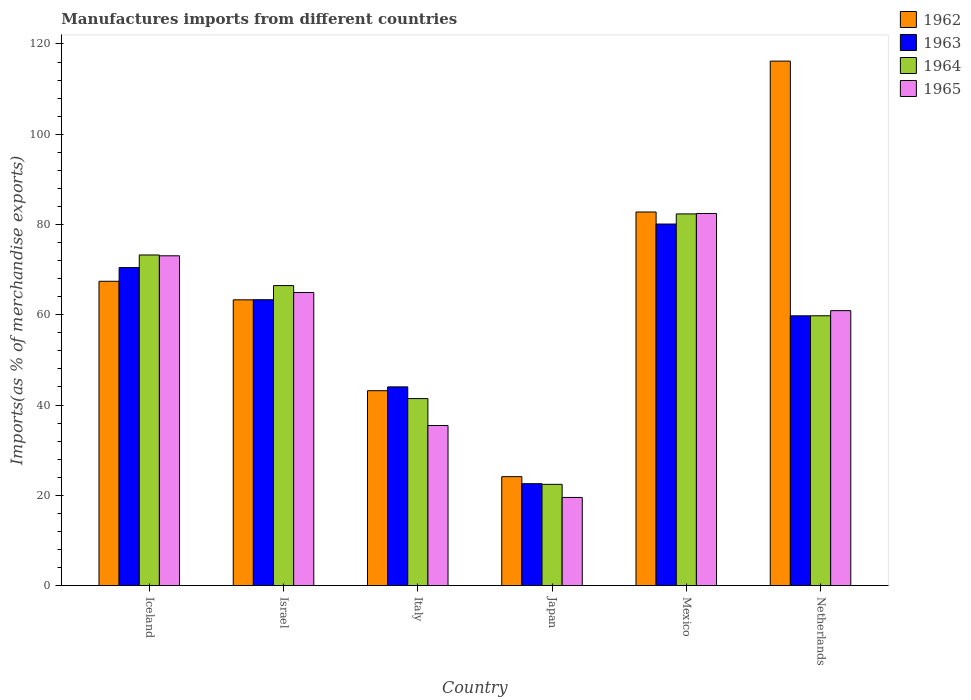How many different coloured bars are there?
Ensure brevity in your answer.  4. Are the number of bars per tick equal to the number of legend labels?
Provide a succinct answer. Yes. Are the number of bars on each tick of the X-axis equal?
Your answer should be compact. Yes. What is the label of the 3rd group of bars from the left?
Offer a terse response. Italy. In how many cases, is the number of bars for a given country not equal to the number of legend labels?
Make the answer very short. 0. What is the percentage of imports to different countries in 1964 in Iceland?
Your answer should be very brief. 73.25. Across all countries, what is the maximum percentage of imports to different countries in 1962?
Keep it short and to the point. 116.21. Across all countries, what is the minimum percentage of imports to different countries in 1965?
Provide a succinct answer. 19.52. In which country was the percentage of imports to different countries in 1962 maximum?
Provide a short and direct response. Netherlands. What is the total percentage of imports to different countries in 1963 in the graph?
Make the answer very short. 340.27. What is the difference between the percentage of imports to different countries in 1965 in Iceland and that in Japan?
Give a very brief answer. 53.54. What is the difference between the percentage of imports to different countries in 1962 in Netherlands and the percentage of imports to different countries in 1965 in Iceland?
Your response must be concise. 43.14. What is the average percentage of imports to different countries in 1964 per country?
Your response must be concise. 57.62. What is the difference between the percentage of imports to different countries of/in 1965 and percentage of imports to different countries of/in 1964 in Mexico?
Keep it short and to the point. 0.09. What is the ratio of the percentage of imports to different countries in 1965 in Israel to that in Netherlands?
Make the answer very short. 1.07. Is the percentage of imports to different countries in 1965 in Israel less than that in Italy?
Provide a short and direct response. No. What is the difference between the highest and the second highest percentage of imports to different countries in 1963?
Offer a very short reply. 9.65. What is the difference between the highest and the lowest percentage of imports to different countries in 1965?
Provide a succinct answer. 62.92. Is it the case that in every country, the sum of the percentage of imports to different countries in 1964 and percentage of imports to different countries in 1962 is greater than the sum of percentage of imports to different countries in 1963 and percentage of imports to different countries in 1965?
Ensure brevity in your answer.  No. What does the 4th bar from the left in Italy represents?
Keep it short and to the point. 1965. What does the 1st bar from the right in Israel represents?
Make the answer very short. 1965. Is it the case that in every country, the sum of the percentage of imports to different countries in 1964 and percentage of imports to different countries in 1963 is greater than the percentage of imports to different countries in 1962?
Offer a terse response. Yes. How many bars are there?
Give a very brief answer. 24. Are all the bars in the graph horizontal?
Offer a very short reply. No. How many countries are there in the graph?
Give a very brief answer. 6. Are the values on the major ticks of Y-axis written in scientific E-notation?
Offer a terse response. No. Does the graph contain any zero values?
Your answer should be very brief. No. Does the graph contain grids?
Give a very brief answer. No. Where does the legend appear in the graph?
Make the answer very short. Top right. How many legend labels are there?
Your answer should be compact. 4. How are the legend labels stacked?
Offer a terse response. Vertical. What is the title of the graph?
Your answer should be compact. Manufactures imports from different countries. What is the label or title of the X-axis?
Make the answer very short. Country. What is the label or title of the Y-axis?
Your answer should be very brief. Imports(as % of merchandise exports). What is the Imports(as % of merchandise exports) in 1962 in Iceland?
Your answer should be compact. 67.42. What is the Imports(as % of merchandise exports) of 1963 in Iceland?
Offer a terse response. 70.45. What is the Imports(as % of merchandise exports) of 1964 in Iceland?
Give a very brief answer. 73.25. What is the Imports(as % of merchandise exports) of 1965 in Iceland?
Ensure brevity in your answer.  73.07. What is the Imports(as % of merchandise exports) in 1962 in Israel?
Your answer should be compact. 63.32. What is the Imports(as % of merchandise exports) of 1963 in Israel?
Give a very brief answer. 63.34. What is the Imports(as % of merchandise exports) in 1964 in Israel?
Offer a very short reply. 66.47. What is the Imports(as % of merchandise exports) of 1965 in Israel?
Ensure brevity in your answer.  64.94. What is the Imports(as % of merchandise exports) in 1962 in Italy?
Give a very brief answer. 43.18. What is the Imports(as % of merchandise exports) of 1963 in Italy?
Ensure brevity in your answer.  44.02. What is the Imports(as % of merchandise exports) of 1964 in Italy?
Your response must be concise. 41.43. What is the Imports(as % of merchandise exports) of 1965 in Italy?
Offer a terse response. 35.47. What is the Imports(as % of merchandise exports) in 1962 in Japan?
Make the answer very short. 24.13. What is the Imports(as % of merchandise exports) in 1963 in Japan?
Give a very brief answer. 22.57. What is the Imports(as % of merchandise exports) of 1964 in Japan?
Offer a terse response. 22.43. What is the Imports(as % of merchandise exports) of 1965 in Japan?
Make the answer very short. 19.52. What is the Imports(as % of merchandise exports) of 1962 in Mexico?
Keep it short and to the point. 82.78. What is the Imports(as % of merchandise exports) in 1963 in Mexico?
Your response must be concise. 80.11. What is the Imports(as % of merchandise exports) of 1964 in Mexico?
Provide a short and direct response. 82.35. What is the Imports(as % of merchandise exports) of 1965 in Mexico?
Your answer should be very brief. 82.44. What is the Imports(as % of merchandise exports) in 1962 in Netherlands?
Keep it short and to the point. 116.21. What is the Imports(as % of merchandise exports) in 1963 in Netherlands?
Offer a very short reply. 59.77. What is the Imports(as % of merchandise exports) of 1964 in Netherlands?
Provide a succinct answer. 59.78. What is the Imports(as % of merchandise exports) of 1965 in Netherlands?
Your response must be concise. 60.91. Across all countries, what is the maximum Imports(as % of merchandise exports) of 1962?
Make the answer very short. 116.21. Across all countries, what is the maximum Imports(as % of merchandise exports) in 1963?
Your response must be concise. 80.11. Across all countries, what is the maximum Imports(as % of merchandise exports) in 1964?
Your response must be concise. 82.35. Across all countries, what is the maximum Imports(as % of merchandise exports) of 1965?
Give a very brief answer. 82.44. Across all countries, what is the minimum Imports(as % of merchandise exports) in 1962?
Offer a terse response. 24.13. Across all countries, what is the minimum Imports(as % of merchandise exports) of 1963?
Provide a succinct answer. 22.57. Across all countries, what is the minimum Imports(as % of merchandise exports) of 1964?
Make the answer very short. 22.43. Across all countries, what is the minimum Imports(as % of merchandise exports) in 1965?
Offer a terse response. 19.52. What is the total Imports(as % of merchandise exports) of 1962 in the graph?
Make the answer very short. 397.04. What is the total Imports(as % of merchandise exports) of 1963 in the graph?
Offer a very short reply. 340.27. What is the total Imports(as % of merchandise exports) in 1964 in the graph?
Provide a short and direct response. 345.71. What is the total Imports(as % of merchandise exports) of 1965 in the graph?
Give a very brief answer. 336.36. What is the difference between the Imports(as % of merchandise exports) of 1962 in Iceland and that in Israel?
Ensure brevity in your answer.  4.11. What is the difference between the Imports(as % of merchandise exports) in 1963 in Iceland and that in Israel?
Your answer should be compact. 7.11. What is the difference between the Imports(as % of merchandise exports) of 1964 in Iceland and that in Israel?
Provide a succinct answer. 6.78. What is the difference between the Imports(as % of merchandise exports) of 1965 in Iceland and that in Israel?
Provide a short and direct response. 8.12. What is the difference between the Imports(as % of merchandise exports) of 1962 in Iceland and that in Italy?
Offer a terse response. 24.24. What is the difference between the Imports(as % of merchandise exports) in 1963 in Iceland and that in Italy?
Make the answer very short. 26.43. What is the difference between the Imports(as % of merchandise exports) in 1964 in Iceland and that in Italy?
Make the answer very short. 31.82. What is the difference between the Imports(as % of merchandise exports) of 1965 in Iceland and that in Italy?
Provide a short and direct response. 37.6. What is the difference between the Imports(as % of merchandise exports) in 1962 in Iceland and that in Japan?
Provide a succinct answer. 43.29. What is the difference between the Imports(as % of merchandise exports) in 1963 in Iceland and that in Japan?
Offer a terse response. 47.88. What is the difference between the Imports(as % of merchandise exports) of 1964 in Iceland and that in Japan?
Keep it short and to the point. 50.82. What is the difference between the Imports(as % of merchandise exports) of 1965 in Iceland and that in Japan?
Make the answer very short. 53.54. What is the difference between the Imports(as % of merchandise exports) in 1962 in Iceland and that in Mexico?
Give a very brief answer. -15.35. What is the difference between the Imports(as % of merchandise exports) in 1963 in Iceland and that in Mexico?
Make the answer very short. -9.65. What is the difference between the Imports(as % of merchandise exports) of 1964 in Iceland and that in Mexico?
Keep it short and to the point. -9.1. What is the difference between the Imports(as % of merchandise exports) of 1965 in Iceland and that in Mexico?
Make the answer very short. -9.38. What is the difference between the Imports(as % of merchandise exports) in 1962 in Iceland and that in Netherlands?
Your answer should be very brief. -48.79. What is the difference between the Imports(as % of merchandise exports) in 1963 in Iceland and that in Netherlands?
Your answer should be compact. 10.68. What is the difference between the Imports(as % of merchandise exports) of 1964 in Iceland and that in Netherlands?
Your answer should be compact. 13.47. What is the difference between the Imports(as % of merchandise exports) of 1965 in Iceland and that in Netherlands?
Provide a short and direct response. 12.15. What is the difference between the Imports(as % of merchandise exports) of 1962 in Israel and that in Italy?
Give a very brief answer. 20.14. What is the difference between the Imports(as % of merchandise exports) of 1963 in Israel and that in Italy?
Provide a short and direct response. 19.32. What is the difference between the Imports(as % of merchandise exports) of 1964 in Israel and that in Italy?
Make the answer very short. 25.04. What is the difference between the Imports(as % of merchandise exports) of 1965 in Israel and that in Italy?
Give a very brief answer. 29.47. What is the difference between the Imports(as % of merchandise exports) in 1962 in Israel and that in Japan?
Keep it short and to the point. 39.19. What is the difference between the Imports(as % of merchandise exports) of 1963 in Israel and that in Japan?
Give a very brief answer. 40.77. What is the difference between the Imports(as % of merchandise exports) in 1964 in Israel and that in Japan?
Keep it short and to the point. 44.04. What is the difference between the Imports(as % of merchandise exports) in 1965 in Israel and that in Japan?
Keep it short and to the point. 45.42. What is the difference between the Imports(as % of merchandise exports) of 1962 in Israel and that in Mexico?
Offer a terse response. -19.46. What is the difference between the Imports(as % of merchandise exports) in 1963 in Israel and that in Mexico?
Provide a short and direct response. -16.77. What is the difference between the Imports(as % of merchandise exports) in 1964 in Israel and that in Mexico?
Make the answer very short. -15.88. What is the difference between the Imports(as % of merchandise exports) of 1965 in Israel and that in Mexico?
Give a very brief answer. -17.5. What is the difference between the Imports(as % of merchandise exports) in 1962 in Israel and that in Netherlands?
Your response must be concise. -52.9. What is the difference between the Imports(as % of merchandise exports) in 1963 in Israel and that in Netherlands?
Your response must be concise. 3.57. What is the difference between the Imports(as % of merchandise exports) in 1964 in Israel and that in Netherlands?
Provide a short and direct response. 6.69. What is the difference between the Imports(as % of merchandise exports) in 1965 in Israel and that in Netherlands?
Provide a succinct answer. 4.03. What is the difference between the Imports(as % of merchandise exports) in 1962 in Italy and that in Japan?
Give a very brief answer. 19.05. What is the difference between the Imports(as % of merchandise exports) in 1963 in Italy and that in Japan?
Offer a terse response. 21.45. What is the difference between the Imports(as % of merchandise exports) of 1964 in Italy and that in Japan?
Provide a short and direct response. 19. What is the difference between the Imports(as % of merchandise exports) in 1965 in Italy and that in Japan?
Provide a succinct answer. 15.94. What is the difference between the Imports(as % of merchandise exports) of 1962 in Italy and that in Mexico?
Your response must be concise. -39.6. What is the difference between the Imports(as % of merchandise exports) in 1963 in Italy and that in Mexico?
Your response must be concise. -36.08. What is the difference between the Imports(as % of merchandise exports) of 1964 in Italy and that in Mexico?
Ensure brevity in your answer.  -40.92. What is the difference between the Imports(as % of merchandise exports) in 1965 in Italy and that in Mexico?
Provide a succinct answer. -46.98. What is the difference between the Imports(as % of merchandise exports) in 1962 in Italy and that in Netherlands?
Your response must be concise. -73.03. What is the difference between the Imports(as % of merchandise exports) of 1963 in Italy and that in Netherlands?
Offer a terse response. -15.75. What is the difference between the Imports(as % of merchandise exports) of 1964 in Italy and that in Netherlands?
Keep it short and to the point. -18.35. What is the difference between the Imports(as % of merchandise exports) of 1965 in Italy and that in Netherlands?
Offer a very short reply. -25.45. What is the difference between the Imports(as % of merchandise exports) in 1962 in Japan and that in Mexico?
Your answer should be compact. -58.65. What is the difference between the Imports(as % of merchandise exports) in 1963 in Japan and that in Mexico?
Offer a terse response. -57.53. What is the difference between the Imports(as % of merchandise exports) of 1964 in Japan and that in Mexico?
Your answer should be compact. -59.92. What is the difference between the Imports(as % of merchandise exports) of 1965 in Japan and that in Mexico?
Provide a succinct answer. -62.92. What is the difference between the Imports(as % of merchandise exports) of 1962 in Japan and that in Netherlands?
Your answer should be very brief. -92.08. What is the difference between the Imports(as % of merchandise exports) in 1963 in Japan and that in Netherlands?
Your answer should be very brief. -37.2. What is the difference between the Imports(as % of merchandise exports) in 1964 in Japan and that in Netherlands?
Your answer should be compact. -37.35. What is the difference between the Imports(as % of merchandise exports) in 1965 in Japan and that in Netherlands?
Keep it short and to the point. -41.39. What is the difference between the Imports(as % of merchandise exports) of 1962 in Mexico and that in Netherlands?
Your answer should be compact. -33.43. What is the difference between the Imports(as % of merchandise exports) in 1963 in Mexico and that in Netherlands?
Your response must be concise. 20.34. What is the difference between the Imports(as % of merchandise exports) of 1964 in Mexico and that in Netherlands?
Offer a very short reply. 22.57. What is the difference between the Imports(as % of merchandise exports) in 1965 in Mexico and that in Netherlands?
Provide a succinct answer. 21.53. What is the difference between the Imports(as % of merchandise exports) of 1962 in Iceland and the Imports(as % of merchandise exports) of 1963 in Israel?
Offer a very short reply. 4.08. What is the difference between the Imports(as % of merchandise exports) of 1962 in Iceland and the Imports(as % of merchandise exports) of 1964 in Israel?
Make the answer very short. 0.95. What is the difference between the Imports(as % of merchandise exports) in 1962 in Iceland and the Imports(as % of merchandise exports) in 1965 in Israel?
Make the answer very short. 2.48. What is the difference between the Imports(as % of merchandise exports) in 1963 in Iceland and the Imports(as % of merchandise exports) in 1964 in Israel?
Ensure brevity in your answer.  3.98. What is the difference between the Imports(as % of merchandise exports) in 1963 in Iceland and the Imports(as % of merchandise exports) in 1965 in Israel?
Your answer should be very brief. 5.51. What is the difference between the Imports(as % of merchandise exports) of 1964 in Iceland and the Imports(as % of merchandise exports) of 1965 in Israel?
Your answer should be compact. 8.31. What is the difference between the Imports(as % of merchandise exports) in 1962 in Iceland and the Imports(as % of merchandise exports) in 1963 in Italy?
Your answer should be very brief. 23.4. What is the difference between the Imports(as % of merchandise exports) of 1962 in Iceland and the Imports(as % of merchandise exports) of 1964 in Italy?
Provide a succinct answer. 25.99. What is the difference between the Imports(as % of merchandise exports) of 1962 in Iceland and the Imports(as % of merchandise exports) of 1965 in Italy?
Ensure brevity in your answer.  31.95. What is the difference between the Imports(as % of merchandise exports) of 1963 in Iceland and the Imports(as % of merchandise exports) of 1964 in Italy?
Make the answer very short. 29.02. What is the difference between the Imports(as % of merchandise exports) in 1963 in Iceland and the Imports(as % of merchandise exports) in 1965 in Italy?
Provide a short and direct response. 34.99. What is the difference between the Imports(as % of merchandise exports) in 1964 in Iceland and the Imports(as % of merchandise exports) in 1965 in Italy?
Ensure brevity in your answer.  37.78. What is the difference between the Imports(as % of merchandise exports) of 1962 in Iceland and the Imports(as % of merchandise exports) of 1963 in Japan?
Make the answer very short. 44.85. What is the difference between the Imports(as % of merchandise exports) of 1962 in Iceland and the Imports(as % of merchandise exports) of 1964 in Japan?
Keep it short and to the point. 45. What is the difference between the Imports(as % of merchandise exports) of 1962 in Iceland and the Imports(as % of merchandise exports) of 1965 in Japan?
Offer a very short reply. 47.9. What is the difference between the Imports(as % of merchandise exports) of 1963 in Iceland and the Imports(as % of merchandise exports) of 1964 in Japan?
Your response must be concise. 48.03. What is the difference between the Imports(as % of merchandise exports) of 1963 in Iceland and the Imports(as % of merchandise exports) of 1965 in Japan?
Offer a terse response. 50.93. What is the difference between the Imports(as % of merchandise exports) in 1964 in Iceland and the Imports(as % of merchandise exports) in 1965 in Japan?
Offer a very short reply. 53.73. What is the difference between the Imports(as % of merchandise exports) in 1962 in Iceland and the Imports(as % of merchandise exports) in 1963 in Mexico?
Ensure brevity in your answer.  -12.68. What is the difference between the Imports(as % of merchandise exports) of 1962 in Iceland and the Imports(as % of merchandise exports) of 1964 in Mexico?
Make the answer very short. -14.93. What is the difference between the Imports(as % of merchandise exports) of 1962 in Iceland and the Imports(as % of merchandise exports) of 1965 in Mexico?
Give a very brief answer. -15.02. What is the difference between the Imports(as % of merchandise exports) of 1963 in Iceland and the Imports(as % of merchandise exports) of 1964 in Mexico?
Provide a succinct answer. -11.9. What is the difference between the Imports(as % of merchandise exports) in 1963 in Iceland and the Imports(as % of merchandise exports) in 1965 in Mexico?
Keep it short and to the point. -11.99. What is the difference between the Imports(as % of merchandise exports) of 1964 in Iceland and the Imports(as % of merchandise exports) of 1965 in Mexico?
Your answer should be compact. -9.19. What is the difference between the Imports(as % of merchandise exports) of 1962 in Iceland and the Imports(as % of merchandise exports) of 1963 in Netherlands?
Your answer should be very brief. 7.65. What is the difference between the Imports(as % of merchandise exports) of 1962 in Iceland and the Imports(as % of merchandise exports) of 1964 in Netherlands?
Your response must be concise. 7.64. What is the difference between the Imports(as % of merchandise exports) of 1962 in Iceland and the Imports(as % of merchandise exports) of 1965 in Netherlands?
Keep it short and to the point. 6.51. What is the difference between the Imports(as % of merchandise exports) in 1963 in Iceland and the Imports(as % of merchandise exports) in 1964 in Netherlands?
Provide a short and direct response. 10.68. What is the difference between the Imports(as % of merchandise exports) of 1963 in Iceland and the Imports(as % of merchandise exports) of 1965 in Netherlands?
Make the answer very short. 9.54. What is the difference between the Imports(as % of merchandise exports) of 1964 in Iceland and the Imports(as % of merchandise exports) of 1965 in Netherlands?
Make the answer very short. 12.34. What is the difference between the Imports(as % of merchandise exports) in 1962 in Israel and the Imports(as % of merchandise exports) in 1963 in Italy?
Your answer should be compact. 19.29. What is the difference between the Imports(as % of merchandise exports) in 1962 in Israel and the Imports(as % of merchandise exports) in 1964 in Italy?
Offer a very short reply. 21.88. What is the difference between the Imports(as % of merchandise exports) in 1962 in Israel and the Imports(as % of merchandise exports) in 1965 in Italy?
Provide a short and direct response. 27.85. What is the difference between the Imports(as % of merchandise exports) of 1963 in Israel and the Imports(as % of merchandise exports) of 1964 in Italy?
Your answer should be compact. 21.91. What is the difference between the Imports(as % of merchandise exports) in 1963 in Israel and the Imports(as % of merchandise exports) in 1965 in Italy?
Keep it short and to the point. 27.87. What is the difference between the Imports(as % of merchandise exports) in 1964 in Israel and the Imports(as % of merchandise exports) in 1965 in Italy?
Ensure brevity in your answer.  31. What is the difference between the Imports(as % of merchandise exports) of 1962 in Israel and the Imports(as % of merchandise exports) of 1963 in Japan?
Give a very brief answer. 40.74. What is the difference between the Imports(as % of merchandise exports) in 1962 in Israel and the Imports(as % of merchandise exports) in 1964 in Japan?
Your answer should be compact. 40.89. What is the difference between the Imports(as % of merchandise exports) in 1962 in Israel and the Imports(as % of merchandise exports) in 1965 in Japan?
Your response must be concise. 43.79. What is the difference between the Imports(as % of merchandise exports) of 1963 in Israel and the Imports(as % of merchandise exports) of 1964 in Japan?
Give a very brief answer. 40.91. What is the difference between the Imports(as % of merchandise exports) in 1963 in Israel and the Imports(as % of merchandise exports) in 1965 in Japan?
Offer a terse response. 43.82. What is the difference between the Imports(as % of merchandise exports) in 1964 in Israel and the Imports(as % of merchandise exports) in 1965 in Japan?
Your answer should be compact. 46.94. What is the difference between the Imports(as % of merchandise exports) in 1962 in Israel and the Imports(as % of merchandise exports) in 1963 in Mexico?
Keep it short and to the point. -16.79. What is the difference between the Imports(as % of merchandise exports) of 1962 in Israel and the Imports(as % of merchandise exports) of 1964 in Mexico?
Give a very brief answer. -19.03. What is the difference between the Imports(as % of merchandise exports) in 1962 in Israel and the Imports(as % of merchandise exports) in 1965 in Mexico?
Provide a short and direct response. -19.13. What is the difference between the Imports(as % of merchandise exports) in 1963 in Israel and the Imports(as % of merchandise exports) in 1964 in Mexico?
Offer a very short reply. -19.01. What is the difference between the Imports(as % of merchandise exports) of 1963 in Israel and the Imports(as % of merchandise exports) of 1965 in Mexico?
Keep it short and to the point. -19.1. What is the difference between the Imports(as % of merchandise exports) of 1964 in Israel and the Imports(as % of merchandise exports) of 1965 in Mexico?
Offer a very short reply. -15.98. What is the difference between the Imports(as % of merchandise exports) in 1962 in Israel and the Imports(as % of merchandise exports) in 1963 in Netherlands?
Provide a succinct answer. 3.54. What is the difference between the Imports(as % of merchandise exports) of 1962 in Israel and the Imports(as % of merchandise exports) of 1964 in Netherlands?
Ensure brevity in your answer.  3.54. What is the difference between the Imports(as % of merchandise exports) in 1962 in Israel and the Imports(as % of merchandise exports) in 1965 in Netherlands?
Your answer should be compact. 2.4. What is the difference between the Imports(as % of merchandise exports) of 1963 in Israel and the Imports(as % of merchandise exports) of 1964 in Netherlands?
Ensure brevity in your answer.  3.56. What is the difference between the Imports(as % of merchandise exports) of 1963 in Israel and the Imports(as % of merchandise exports) of 1965 in Netherlands?
Offer a very short reply. 2.42. What is the difference between the Imports(as % of merchandise exports) of 1964 in Israel and the Imports(as % of merchandise exports) of 1965 in Netherlands?
Your response must be concise. 5.55. What is the difference between the Imports(as % of merchandise exports) of 1962 in Italy and the Imports(as % of merchandise exports) of 1963 in Japan?
Ensure brevity in your answer.  20.61. What is the difference between the Imports(as % of merchandise exports) of 1962 in Italy and the Imports(as % of merchandise exports) of 1964 in Japan?
Your answer should be very brief. 20.75. What is the difference between the Imports(as % of merchandise exports) in 1962 in Italy and the Imports(as % of merchandise exports) in 1965 in Japan?
Your answer should be very brief. 23.66. What is the difference between the Imports(as % of merchandise exports) of 1963 in Italy and the Imports(as % of merchandise exports) of 1964 in Japan?
Offer a very short reply. 21.6. What is the difference between the Imports(as % of merchandise exports) of 1963 in Italy and the Imports(as % of merchandise exports) of 1965 in Japan?
Keep it short and to the point. 24.5. What is the difference between the Imports(as % of merchandise exports) in 1964 in Italy and the Imports(as % of merchandise exports) in 1965 in Japan?
Give a very brief answer. 21.91. What is the difference between the Imports(as % of merchandise exports) of 1962 in Italy and the Imports(as % of merchandise exports) of 1963 in Mexico?
Keep it short and to the point. -36.93. What is the difference between the Imports(as % of merchandise exports) in 1962 in Italy and the Imports(as % of merchandise exports) in 1964 in Mexico?
Give a very brief answer. -39.17. What is the difference between the Imports(as % of merchandise exports) of 1962 in Italy and the Imports(as % of merchandise exports) of 1965 in Mexico?
Your response must be concise. -39.26. What is the difference between the Imports(as % of merchandise exports) in 1963 in Italy and the Imports(as % of merchandise exports) in 1964 in Mexico?
Make the answer very short. -38.33. What is the difference between the Imports(as % of merchandise exports) in 1963 in Italy and the Imports(as % of merchandise exports) in 1965 in Mexico?
Provide a succinct answer. -38.42. What is the difference between the Imports(as % of merchandise exports) of 1964 in Italy and the Imports(as % of merchandise exports) of 1965 in Mexico?
Ensure brevity in your answer.  -41.01. What is the difference between the Imports(as % of merchandise exports) of 1962 in Italy and the Imports(as % of merchandise exports) of 1963 in Netherlands?
Your answer should be compact. -16.59. What is the difference between the Imports(as % of merchandise exports) in 1962 in Italy and the Imports(as % of merchandise exports) in 1964 in Netherlands?
Your answer should be compact. -16.6. What is the difference between the Imports(as % of merchandise exports) in 1962 in Italy and the Imports(as % of merchandise exports) in 1965 in Netherlands?
Offer a terse response. -17.73. What is the difference between the Imports(as % of merchandise exports) in 1963 in Italy and the Imports(as % of merchandise exports) in 1964 in Netherlands?
Ensure brevity in your answer.  -15.75. What is the difference between the Imports(as % of merchandise exports) of 1963 in Italy and the Imports(as % of merchandise exports) of 1965 in Netherlands?
Offer a terse response. -16.89. What is the difference between the Imports(as % of merchandise exports) in 1964 in Italy and the Imports(as % of merchandise exports) in 1965 in Netherlands?
Make the answer very short. -19.48. What is the difference between the Imports(as % of merchandise exports) in 1962 in Japan and the Imports(as % of merchandise exports) in 1963 in Mexico?
Ensure brevity in your answer.  -55.98. What is the difference between the Imports(as % of merchandise exports) of 1962 in Japan and the Imports(as % of merchandise exports) of 1964 in Mexico?
Keep it short and to the point. -58.22. What is the difference between the Imports(as % of merchandise exports) of 1962 in Japan and the Imports(as % of merchandise exports) of 1965 in Mexico?
Provide a succinct answer. -58.32. What is the difference between the Imports(as % of merchandise exports) of 1963 in Japan and the Imports(as % of merchandise exports) of 1964 in Mexico?
Provide a short and direct response. -59.78. What is the difference between the Imports(as % of merchandise exports) of 1963 in Japan and the Imports(as % of merchandise exports) of 1965 in Mexico?
Offer a very short reply. -59.87. What is the difference between the Imports(as % of merchandise exports) of 1964 in Japan and the Imports(as % of merchandise exports) of 1965 in Mexico?
Your answer should be very brief. -60.02. What is the difference between the Imports(as % of merchandise exports) of 1962 in Japan and the Imports(as % of merchandise exports) of 1963 in Netherlands?
Offer a very short reply. -35.64. What is the difference between the Imports(as % of merchandise exports) in 1962 in Japan and the Imports(as % of merchandise exports) in 1964 in Netherlands?
Offer a terse response. -35.65. What is the difference between the Imports(as % of merchandise exports) of 1962 in Japan and the Imports(as % of merchandise exports) of 1965 in Netherlands?
Your answer should be very brief. -36.79. What is the difference between the Imports(as % of merchandise exports) of 1963 in Japan and the Imports(as % of merchandise exports) of 1964 in Netherlands?
Provide a short and direct response. -37.2. What is the difference between the Imports(as % of merchandise exports) of 1963 in Japan and the Imports(as % of merchandise exports) of 1965 in Netherlands?
Provide a short and direct response. -38.34. What is the difference between the Imports(as % of merchandise exports) in 1964 in Japan and the Imports(as % of merchandise exports) in 1965 in Netherlands?
Make the answer very short. -38.49. What is the difference between the Imports(as % of merchandise exports) in 1962 in Mexico and the Imports(as % of merchandise exports) in 1963 in Netherlands?
Your answer should be compact. 23.01. What is the difference between the Imports(as % of merchandise exports) of 1962 in Mexico and the Imports(as % of merchandise exports) of 1964 in Netherlands?
Offer a very short reply. 23. What is the difference between the Imports(as % of merchandise exports) of 1962 in Mexico and the Imports(as % of merchandise exports) of 1965 in Netherlands?
Provide a succinct answer. 21.86. What is the difference between the Imports(as % of merchandise exports) of 1963 in Mexico and the Imports(as % of merchandise exports) of 1964 in Netherlands?
Offer a terse response. 20.33. What is the difference between the Imports(as % of merchandise exports) in 1963 in Mexico and the Imports(as % of merchandise exports) in 1965 in Netherlands?
Ensure brevity in your answer.  19.19. What is the difference between the Imports(as % of merchandise exports) of 1964 in Mexico and the Imports(as % of merchandise exports) of 1965 in Netherlands?
Keep it short and to the point. 21.44. What is the average Imports(as % of merchandise exports) in 1962 per country?
Offer a very short reply. 66.17. What is the average Imports(as % of merchandise exports) in 1963 per country?
Provide a short and direct response. 56.71. What is the average Imports(as % of merchandise exports) in 1964 per country?
Provide a succinct answer. 57.62. What is the average Imports(as % of merchandise exports) in 1965 per country?
Offer a terse response. 56.06. What is the difference between the Imports(as % of merchandise exports) in 1962 and Imports(as % of merchandise exports) in 1963 in Iceland?
Make the answer very short. -3.03. What is the difference between the Imports(as % of merchandise exports) in 1962 and Imports(as % of merchandise exports) in 1964 in Iceland?
Offer a very short reply. -5.83. What is the difference between the Imports(as % of merchandise exports) in 1962 and Imports(as % of merchandise exports) in 1965 in Iceland?
Offer a terse response. -5.64. What is the difference between the Imports(as % of merchandise exports) of 1963 and Imports(as % of merchandise exports) of 1964 in Iceland?
Keep it short and to the point. -2.8. What is the difference between the Imports(as % of merchandise exports) of 1963 and Imports(as % of merchandise exports) of 1965 in Iceland?
Provide a short and direct response. -2.61. What is the difference between the Imports(as % of merchandise exports) in 1964 and Imports(as % of merchandise exports) in 1965 in Iceland?
Your response must be concise. 0.18. What is the difference between the Imports(as % of merchandise exports) of 1962 and Imports(as % of merchandise exports) of 1963 in Israel?
Keep it short and to the point. -0.02. What is the difference between the Imports(as % of merchandise exports) in 1962 and Imports(as % of merchandise exports) in 1964 in Israel?
Provide a succinct answer. -3.15. What is the difference between the Imports(as % of merchandise exports) in 1962 and Imports(as % of merchandise exports) in 1965 in Israel?
Offer a terse response. -1.63. What is the difference between the Imports(as % of merchandise exports) of 1963 and Imports(as % of merchandise exports) of 1964 in Israel?
Provide a short and direct response. -3.13. What is the difference between the Imports(as % of merchandise exports) in 1963 and Imports(as % of merchandise exports) in 1965 in Israel?
Provide a short and direct response. -1.6. What is the difference between the Imports(as % of merchandise exports) of 1964 and Imports(as % of merchandise exports) of 1965 in Israel?
Your answer should be very brief. 1.53. What is the difference between the Imports(as % of merchandise exports) of 1962 and Imports(as % of merchandise exports) of 1963 in Italy?
Make the answer very short. -0.84. What is the difference between the Imports(as % of merchandise exports) in 1962 and Imports(as % of merchandise exports) in 1964 in Italy?
Your answer should be very brief. 1.75. What is the difference between the Imports(as % of merchandise exports) in 1962 and Imports(as % of merchandise exports) in 1965 in Italy?
Your answer should be compact. 7.71. What is the difference between the Imports(as % of merchandise exports) in 1963 and Imports(as % of merchandise exports) in 1964 in Italy?
Your response must be concise. 2.59. What is the difference between the Imports(as % of merchandise exports) in 1963 and Imports(as % of merchandise exports) in 1965 in Italy?
Give a very brief answer. 8.56. What is the difference between the Imports(as % of merchandise exports) in 1964 and Imports(as % of merchandise exports) in 1965 in Italy?
Make the answer very short. 5.96. What is the difference between the Imports(as % of merchandise exports) of 1962 and Imports(as % of merchandise exports) of 1963 in Japan?
Your answer should be very brief. 1.55. What is the difference between the Imports(as % of merchandise exports) of 1962 and Imports(as % of merchandise exports) of 1964 in Japan?
Make the answer very short. 1.7. What is the difference between the Imports(as % of merchandise exports) of 1962 and Imports(as % of merchandise exports) of 1965 in Japan?
Provide a succinct answer. 4.6. What is the difference between the Imports(as % of merchandise exports) in 1963 and Imports(as % of merchandise exports) in 1964 in Japan?
Provide a succinct answer. 0.15. What is the difference between the Imports(as % of merchandise exports) of 1963 and Imports(as % of merchandise exports) of 1965 in Japan?
Provide a short and direct response. 3.05. What is the difference between the Imports(as % of merchandise exports) in 1964 and Imports(as % of merchandise exports) in 1965 in Japan?
Ensure brevity in your answer.  2.9. What is the difference between the Imports(as % of merchandise exports) of 1962 and Imports(as % of merchandise exports) of 1963 in Mexico?
Keep it short and to the point. 2.67. What is the difference between the Imports(as % of merchandise exports) in 1962 and Imports(as % of merchandise exports) in 1964 in Mexico?
Offer a terse response. 0.43. What is the difference between the Imports(as % of merchandise exports) of 1962 and Imports(as % of merchandise exports) of 1965 in Mexico?
Your answer should be very brief. 0.33. What is the difference between the Imports(as % of merchandise exports) in 1963 and Imports(as % of merchandise exports) in 1964 in Mexico?
Offer a very short reply. -2.24. What is the difference between the Imports(as % of merchandise exports) of 1963 and Imports(as % of merchandise exports) of 1965 in Mexico?
Your answer should be compact. -2.34. What is the difference between the Imports(as % of merchandise exports) of 1964 and Imports(as % of merchandise exports) of 1965 in Mexico?
Offer a very short reply. -0.09. What is the difference between the Imports(as % of merchandise exports) of 1962 and Imports(as % of merchandise exports) of 1963 in Netherlands?
Your response must be concise. 56.44. What is the difference between the Imports(as % of merchandise exports) in 1962 and Imports(as % of merchandise exports) in 1964 in Netherlands?
Provide a succinct answer. 56.43. What is the difference between the Imports(as % of merchandise exports) in 1962 and Imports(as % of merchandise exports) in 1965 in Netherlands?
Give a very brief answer. 55.3. What is the difference between the Imports(as % of merchandise exports) of 1963 and Imports(as % of merchandise exports) of 1964 in Netherlands?
Your response must be concise. -0.01. What is the difference between the Imports(as % of merchandise exports) in 1963 and Imports(as % of merchandise exports) in 1965 in Netherlands?
Your response must be concise. -1.14. What is the difference between the Imports(as % of merchandise exports) of 1964 and Imports(as % of merchandise exports) of 1965 in Netherlands?
Offer a very short reply. -1.14. What is the ratio of the Imports(as % of merchandise exports) of 1962 in Iceland to that in Israel?
Your answer should be compact. 1.06. What is the ratio of the Imports(as % of merchandise exports) of 1963 in Iceland to that in Israel?
Offer a terse response. 1.11. What is the ratio of the Imports(as % of merchandise exports) of 1964 in Iceland to that in Israel?
Make the answer very short. 1.1. What is the ratio of the Imports(as % of merchandise exports) of 1965 in Iceland to that in Israel?
Keep it short and to the point. 1.13. What is the ratio of the Imports(as % of merchandise exports) of 1962 in Iceland to that in Italy?
Make the answer very short. 1.56. What is the ratio of the Imports(as % of merchandise exports) in 1963 in Iceland to that in Italy?
Your response must be concise. 1.6. What is the ratio of the Imports(as % of merchandise exports) of 1964 in Iceland to that in Italy?
Offer a terse response. 1.77. What is the ratio of the Imports(as % of merchandise exports) in 1965 in Iceland to that in Italy?
Provide a succinct answer. 2.06. What is the ratio of the Imports(as % of merchandise exports) in 1962 in Iceland to that in Japan?
Offer a very short reply. 2.79. What is the ratio of the Imports(as % of merchandise exports) of 1963 in Iceland to that in Japan?
Keep it short and to the point. 3.12. What is the ratio of the Imports(as % of merchandise exports) of 1964 in Iceland to that in Japan?
Keep it short and to the point. 3.27. What is the ratio of the Imports(as % of merchandise exports) in 1965 in Iceland to that in Japan?
Provide a succinct answer. 3.74. What is the ratio of the Imports(as % of merchandise exports) in 1962 in Iceland to that in Mexico?
Your response must be concise. 0.81. What is the ratio of the Imports(as % of merchandise exports) in 1963 in Iceland to that in Mexico?
Ensure brevity in your answer.  0.88. What is the ratio of the Imports(as % of merchandise exports) of 1964 in Iceland to that in Mexico?
Provide a short and direct response. 0.89. What is the ratio of the Imports(as % of merchandise exports) in 1965 in Iceland to that in Mexico?
Ensure brevity in your answer.  0.89. What is the ratio of the Imports(as % of merchandise exports) in 1962 in Iceland to that in Netherlands?
Your answer should be compact. 0.58. What is the ratio of the Imports(as % of merchandise exports) of 1963 in Iceland to that in Netherlands?
Provide a short and direct response. 1.18. What is the ratio of the Imports(as % of merchandise exports) in 1964 in Iceland to that in Netherlands?
Your response must be concise. 1.23. What is the ratio of the Imports(as % of merchandise exports) in 1965 in Iceland to that in Netherlands?
Your answer should be very brief. 1.2. What is the ratio of the Imports(as % of merchandise exports) of 1962 in Israel to that in Italy?
Keep it short and to the point. 1.47. What is the ratio of the Imports(as % of merchandise exports) of 1963 in Israel to that in Italy?
Keep it short and to the point. 1.44. What is the ratio of the Imports(as % of merchandise exports) in 1964 in Israel to that in Italy?
Keep it short and to the point. 1.6. What is the ratio of the Imports(as % of merchandise exports) of 1965 in Israel to that in Italy?
Provide a succinct answer. 1.83. What is the ratio of the Imports(as % of merchandise exports) in 1962 in Israel to that in Japan?
Provide a short and direct response. 2.62. What is the ratio of the Imports(as % of merchandise exports) of 1963 in Israel to that in Japan?
Your answer should be compact. 2.81. What is the ratio of the Imports(as % of merchandise exports) in 1964 in Israel to that in Japan?
Offer a very short reply. 2.96. What is the ratio of the Imports(as % of merchandise exports) of 1965 in Israel to that in Japan?
Your answer should be compact. 3.33. What is the ratio of the Imports(as % of merchandise exports) in 1962 in Israel to that in Mexico?
Offer a terse response. 0.76. What is the ratio of the Imports(as % of merchandise exports) in 1963 in Israel to that in Mexico?
Your answer should be very brief. 0.79. What is the ratio of the Imports(as % of merchandise exports) of 1964 in Israel to that in Mexico?
Provide a succinct answer. 0.81. What is the ratio of the Imports(as % of merchandise exports) of 1965 in Israel to that in Mexico?
Your answer should be compact. 0.79. What is the ratio of the Imports(as % of merchandise exports) in 1962 in Israel to that in Netherlands?
Provide a succinct answer. 0.54. What is the ratio of the Imports(as % of merchandise exports) in 1963 in Israel to that in Netherlands?
Offer a very short reply. 1.06. What is the ratio of the Imports(as % of merchandise exports) in 1964 in Israel to that in Netherlands?
Provide a succinct answer. 1.11. What is the ratio of the Imports(as % of merchandise exports) in 1965 in Israel to that in Netherlands?
Provide a succinct answer. 1.07. What is the ratio of the Imports(as % of merchandise exports) of 1962 in Italy to that in Japan?
Provide a short and direct response. 1.79. What is the ratio of the Imports(as % of merchandise exports) in 1963 in Italy to that in Japan?
Keep it short and to the point. 1.95. What is the ratio of the Imports(as % of merchandise exports) of 1964 in Italy to that in Japan?
Your answer should be very brief. 1.85. What is the ratio of the Imports(as % of merchandise exports) of 1965 in Italy to that in Japan?
Give a very brief answer. 1.82. What is the ratio of the Imports(as % of merchandise exports) of 1962 in Italy to that in Mexico?
Offer a terse response. 0.52. What is the ratio of the Imports(as % of merchandise exports) of 1963 in Italy to that in Mexico?
Provide a succinct answer. 0.55. What is the ratio of the Imports(as % of merchandise exports) of 1964 in Italy to that in Mexico?
Make the answer very short. 0.5. What is the ratio of the Imports(as % of merchandise exports) of 1965 in Italy to that in Mexico?
Provide a succinct answer. 0.43. What is the ratio of the Imports(as % of merchandise exports) in 1962 in Italy to that in Netherlands?
Offer a terse response. 0.37. What is the ratio of the Imports(as % of merchandise exports) of 1963 in Italy to that in Netherlands?
Your answer should be compact. 0.74. What is the ratio of the Imports(as % of merchandise exports) in 1964 in Italy to that in Netherlands?
Provide a succinct answer. 0.69. What is the ratio of the Imports(as % of merchandise exports) of 1965 in Italy to that in Netherlands?
Make the answer very short. 0.58. What is the ratio of the Imports(as % of merchandise exports) in 1962 in Japan to that in Mexico?
Provide a short and direct response. 0.29. What is the ratio of the Imports(as % of merchandise exports) in 1963 in Japan to that in Mexico?
Make the answer very short. 0.28. What is the ratio of the Imports(as % of merchandise exports) of 1964 in Japan to that in Mexico?
Provide a short and direct response. 0.27. What is the ratio of the Imports(as % of merchandise exports) of 1965 in Japan to that in Mexico?
Provide a short and direct response. 0.24. What is the ratio of the Imports(as % of merchandise exports) in 1962 in Japan to that in Netherlands?
Your answer should be very brief. 0.21. What is the ratio of the Imports(as % of merchandise exports) in 1963 in Japan to that in Netherlands?
Your response must be concise. 0.38. What is the ratio of the Imports(as % of merchandise exports) in 1964 in Japan to that in Netherlands?
Your response must be concise. 0.38. What is the ratio of the Imports(as % of merchandise exports) in 1965 in Japan to that in Netherlands?
Make the answer very short. 0.32. What is the ratio of the Imports(as % of merchandise exports) of 1962 in Mexico to that in Netherlands?
Give a very brief answer. 0.71. What is the ratio of the Imports(as % of merchandise exports) in 1963 in Mexico to that in Netherlands?
Ensure brevity in your answer.  1.34. What is the ratio of the Imports(as % of merchandise exports) of 1964 in Mexico to that in Netherlands?
Keep it short and to the point. 1.38. What is the ratio of the Imports(as % of merchandise exports) in 1965 in Mexico to that in Netherlands?
Your response must be concise. 1.35. What is the difference between the highest and the second highest Imports(as % of merchandise exports) in 1962?
Provide a short and direct response. 33.43. What is the difference between the highest and the second highest Imports(as % of merchandise exports) in 1963?
Provide a succinct answer. 9.65. What is the difference between the highest and the second highest Imports(as % of merchandise exports) of 1964?
Offer a terse response. 9.1. What is the difference between the highest and the second highest Imports(as % of merchandise exports) in 1965?
Your answer should be compact. 9.38. What is the difference between the highest and the lowest Imports(as % of merchandise exports) of 1962?
Offer a very short reply. 92.08. What is the difference between the highest and the lowest Imports(as % of merchandise exports) of 1963?
Give a very brief answer. 57.53. What is the difference between the highest and the lowest Imports(as % of merchandise exports) in 1964?
Provide a short and direct response. 59.92. What is the difference between the highest and the lowest Imports(as % of merchandise exports) in 1965?
Provide a short and direct response. 62.92. 